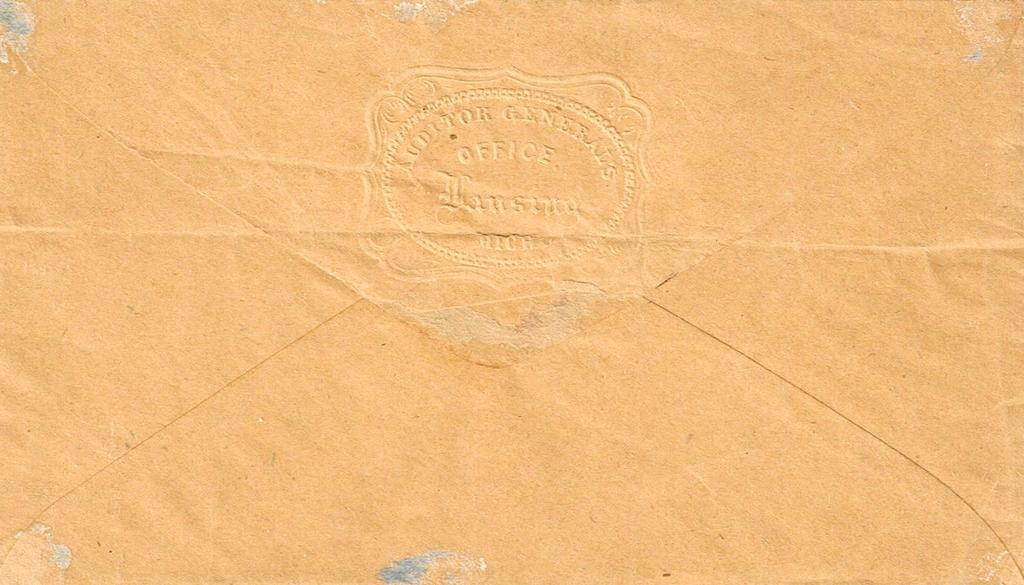Provide a one-sentence caption for the provided image. AN ENVELOP WITH THE WRITING "AUDITOR GENERAL OFFICE" ON IT. 